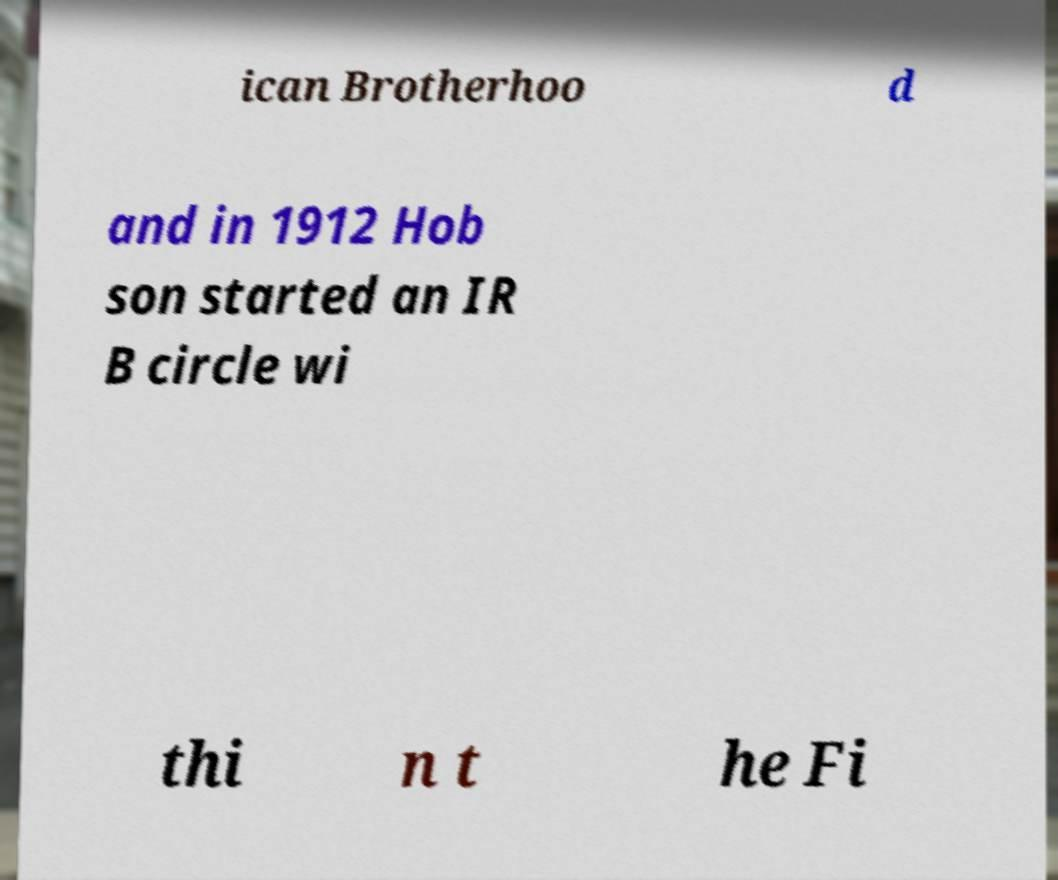Please identify and transcribe the text found in this image. ican Brotherhoo d and in 1912 Hob son started an IR B circle wi thi n t he Fi 